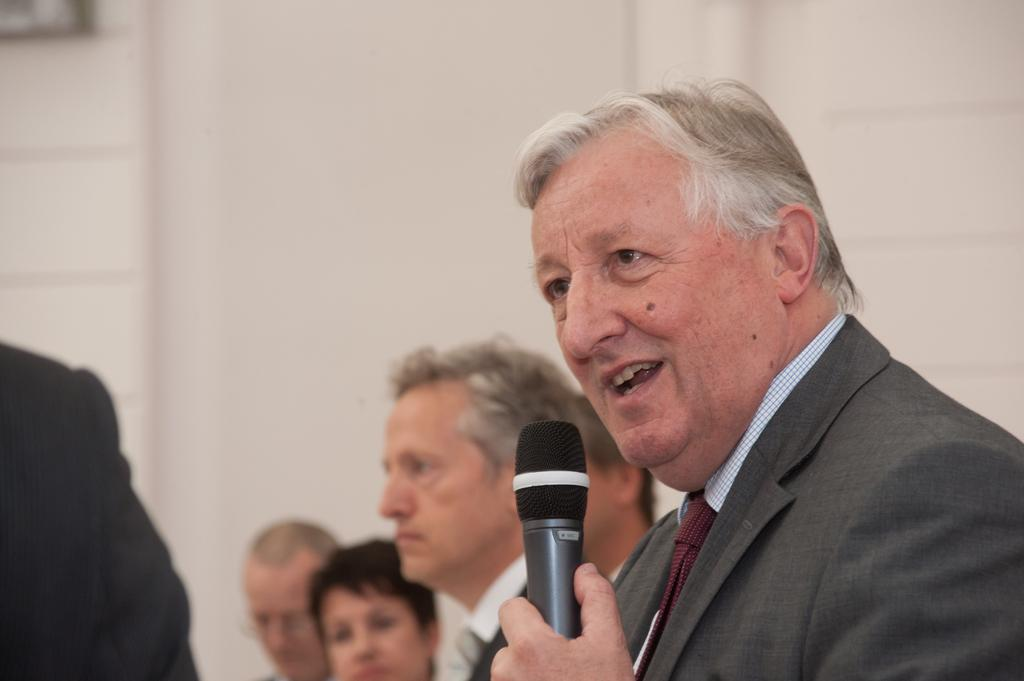How many men are present in the image? There are multiple men in the image. What is one of the men doing in the image? One of the men is speaking on a microphone. What type of match is being played in the image? There is no match being played in the image; it only shows multiple men, one of whom is speaking on a microphone. How is the balance of the wood maintained in the image? There is no wood present in the image, so the balance of any wood cannot be determined. 